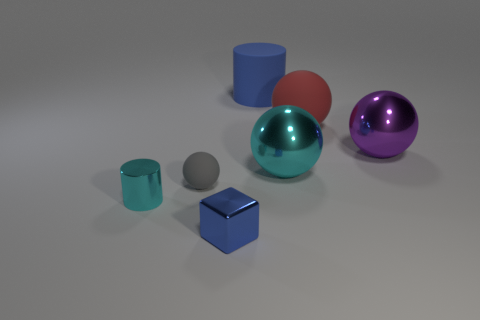Subtract all tiny rubber balls. How many balls are left? 3 Subtract all purple spheres. How many spheres are left? 3 Subtract 1 spheres. How many spheres are left? 3 Add 3 small green metal balls. How many objects exist? 10 Subtract all yellow balls. Subtract all purple cylinders. How many balls are left? 4 Subtract all balls. How many objects are left? 3 Subtract 1 purple balls. How many objects are left? 6 Subtract all tiny purple rubber cylinders. Subtract all blocks. How many objects are left? 6 Add 5 tiny cyan metal objects. How many tiny cyan metal objects are left? 6 Add 2 blue things. How many blue things exist? 4 